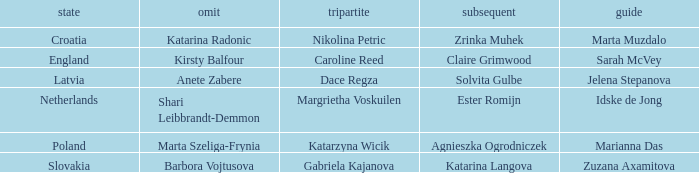Which lead has Kirsty Balfour as second? Sarah McVey. 